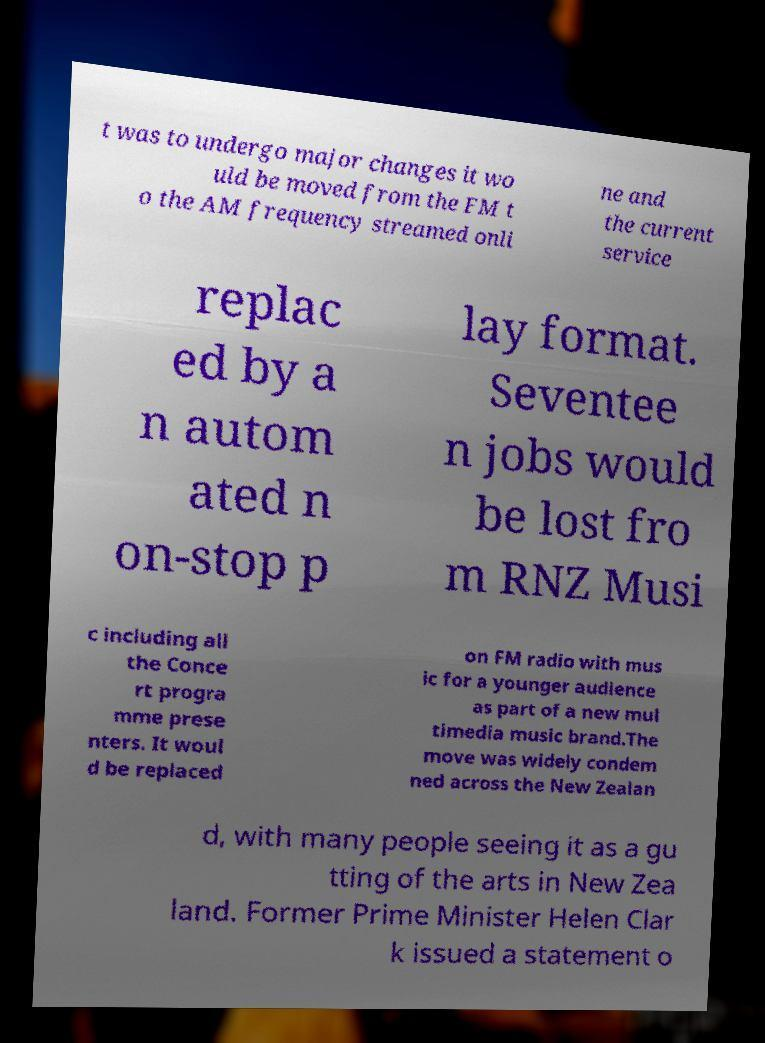I need the written content from this picture converted into text. Can you do that? t was to undergo major changes it wo uld be moved from the FM t o the AM frequency streamed onli ne and the current service replac ed by a n autom ated n on-stop p lay format. Seventee n jobs would be lost fro m RNZ Musi c including all the Conce rt progra mme prese nters. It woul d be replaced on FM radio with mus ic for a younger audience as part of a new mul timedia music brand.The move was widely condem ned across the New Zealan d, with many people seeing it as a gu tting of the arts in New Zea land. Former Prime Minister Helen Clar k issued a statement o 